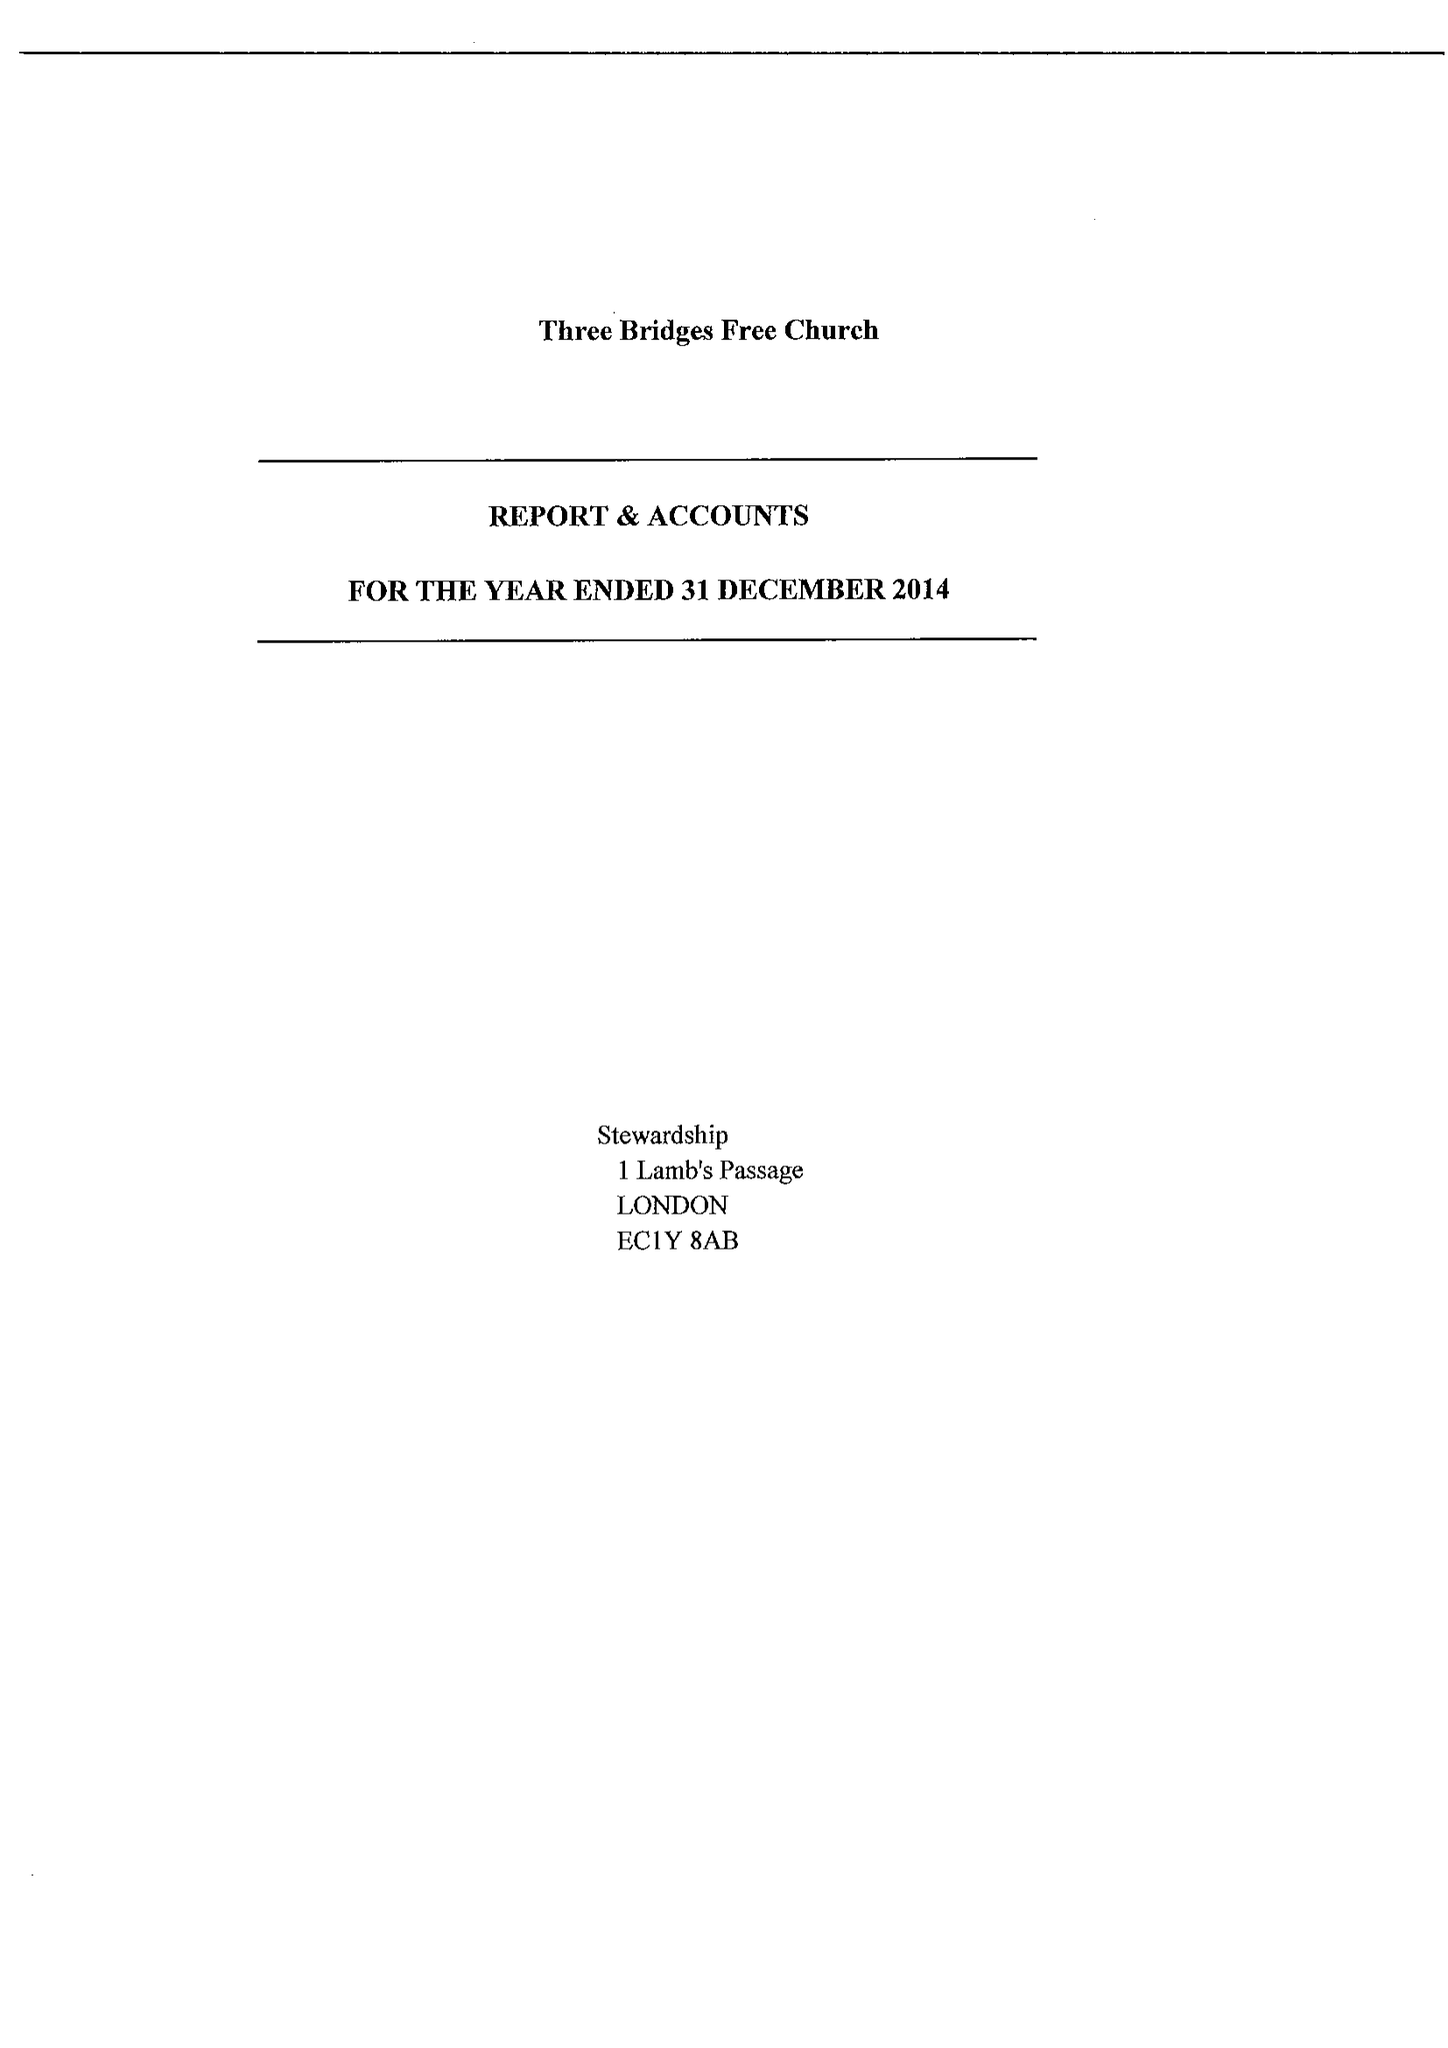What is the value for the address__street_line?
Answer the question using a single word or phrase. THREE BRIDGES ROAD 